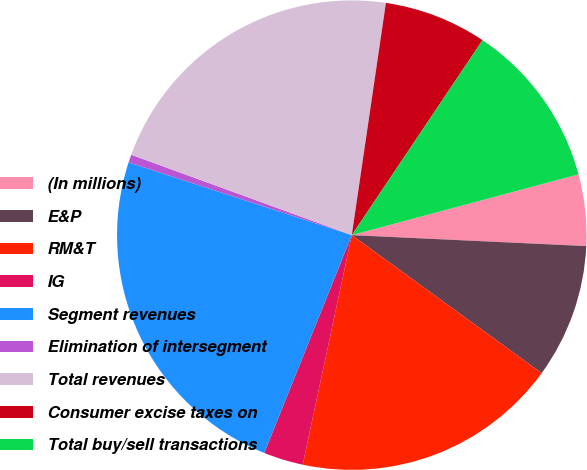Convert chart. <chart><loc_0><loc_0><loc_500><loc_500><pie_chart><fcel>(In millions)<fcel>E&P<fcel>RM&T<fcel>IG<fcel>Segment revenues<fcel>Elimination of intersegment<fcel>Total revenues<fcel>Consumer excise taxes on<fcel>Total buy/sell transactions<nl><fcel>4.91%<fcel>9.26%<fcel>18.35%<fcel>2.73%<fcel>23.93%<fcel>0.55%<fcel>21.76%<fcel>7.08%<fcel>11.43%<nl></chart> 